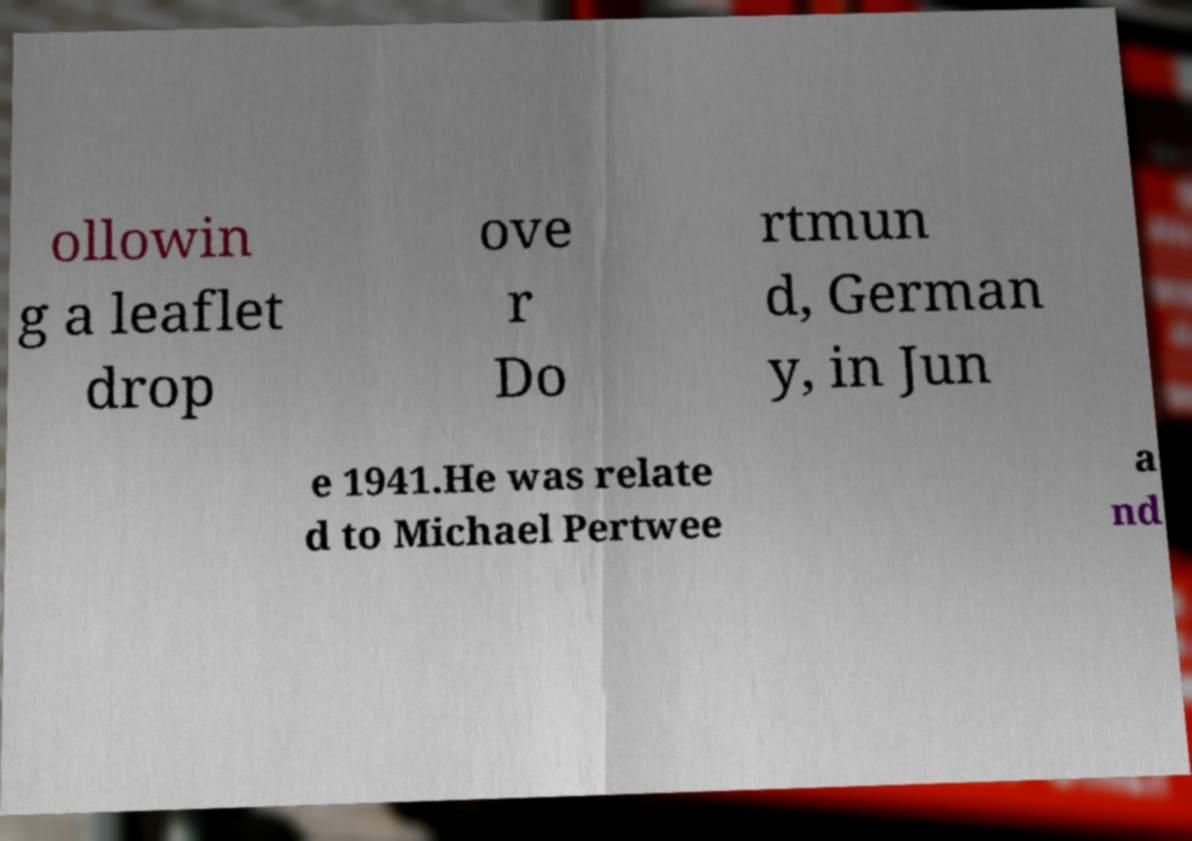What messages or text are displayed in this image? I need them in a readable, typed format. ollowin g a leaflet drop ove r Do rtmun d, German y, in Jun e 1941.He was relate d to Michael Pertwee a nd 